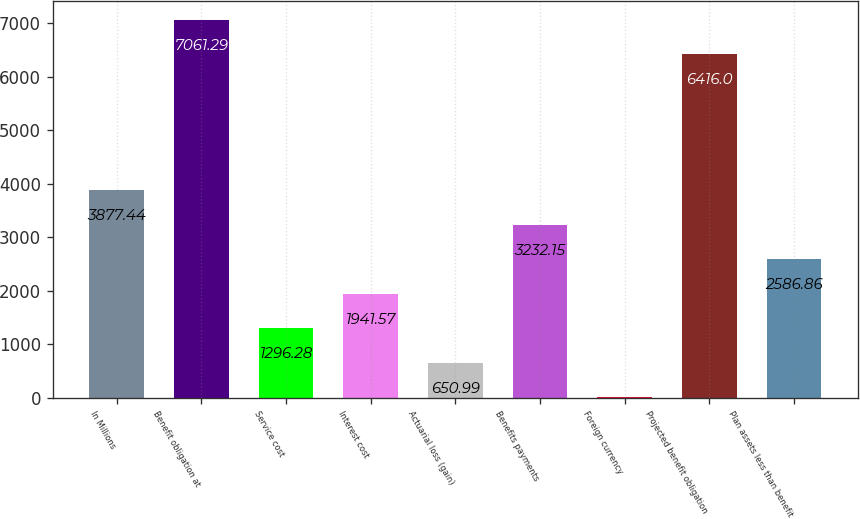Convert chart to OTSL. <chart><loc_0><loc_0><loc_500><loc_500><bar_chart><fcel>In Millions<fcel>Benefit obligation at<fcel>Service cost<fcel>Interest cost<fcel>Actuarial loss (gain)<fcel>Benefits payments<fcel>Foreign currency<fcel>Projected benefit obligation<fcel>Plan assets less than benefit<nl><fcel>3877.44<fcel>7061.29<fcel>1296.28<fcel>1941.57<fcel>650.99<fcel>3232.15<fcel>5.7<fcel>6416<fcel>2586.86<nl></chart> 